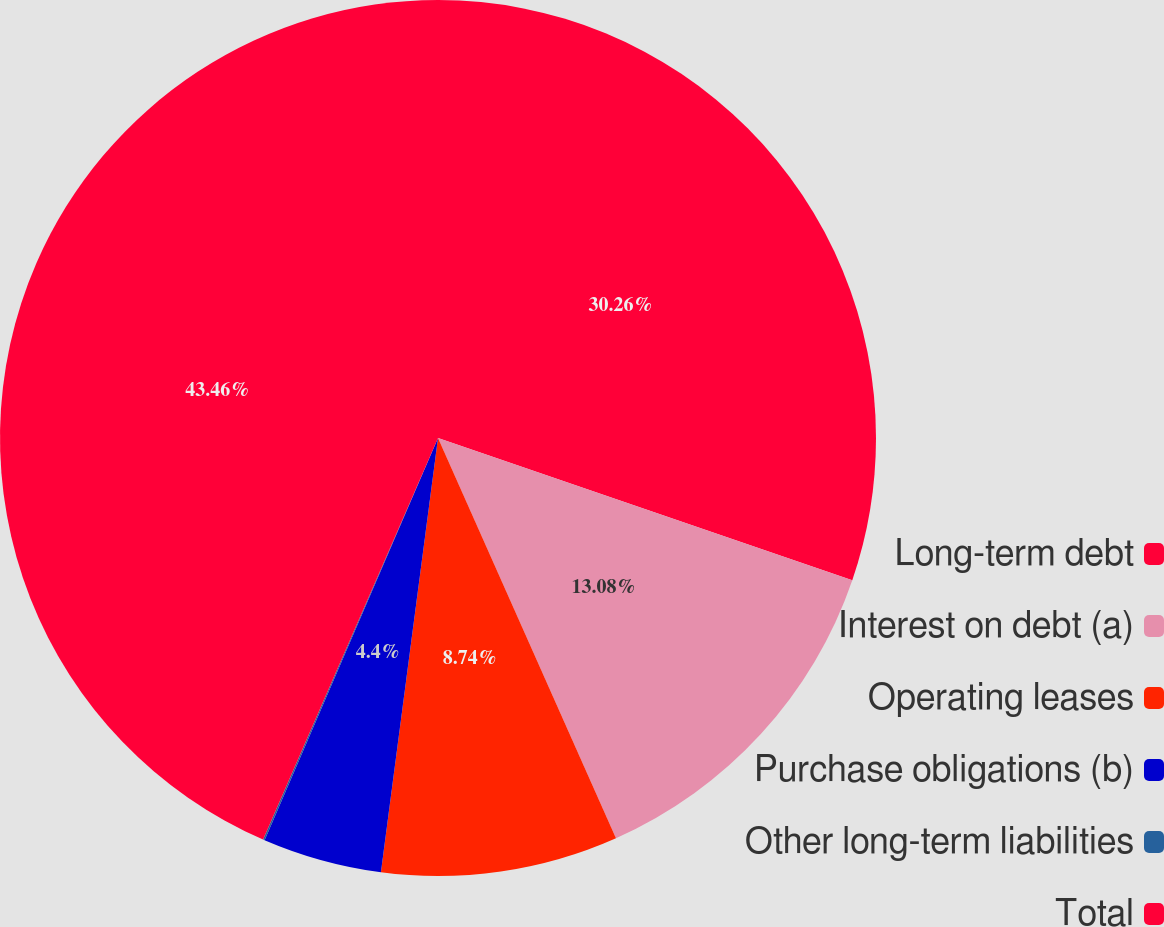Convert chart. <chart><loc_0><loc_0><loc_500><loc_500><pie_chart><fcel>Long-term debt<fcel>Interest on debt (a)<fcel>Operating leases<fcel>Purchase obligations (b)<fcel>Other long-term liabilities<fcel>Total<nl><fcel>30.26%<fcel>13.08%<fcel>8.74%<fcel>4.4%<fcel>0.06%<fcel>43.46%<nl></chart> 